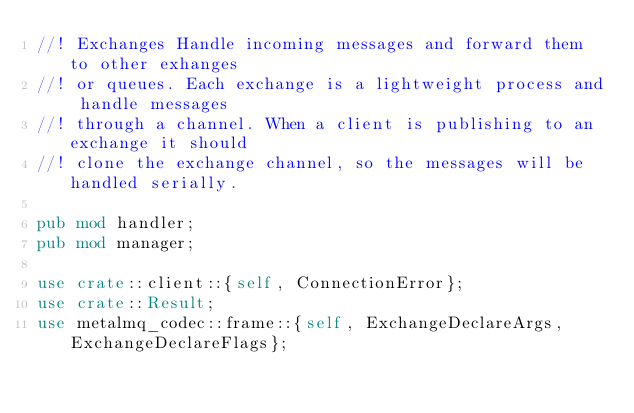Convert code to text. <code><loc_0><loc_0><loc_500><loc_500><_Rust_>//! Exchanges Handle incoming messages and forward them to other exhanges
//! or queues. Each exchange is a lightweight process and handle messages
//! through a channel. When a client is publishing to an exchange it should
//! clone the exchange channel, so the messages will be handled serially.

pub mod handler;
pub mod manager;

use crate::client::{self, ConnectionError};
use crate::Result;
use metalmq_codec::frame::{self, ExchangeDeclareArgs, ExchangeDeclareFlags};</code> 